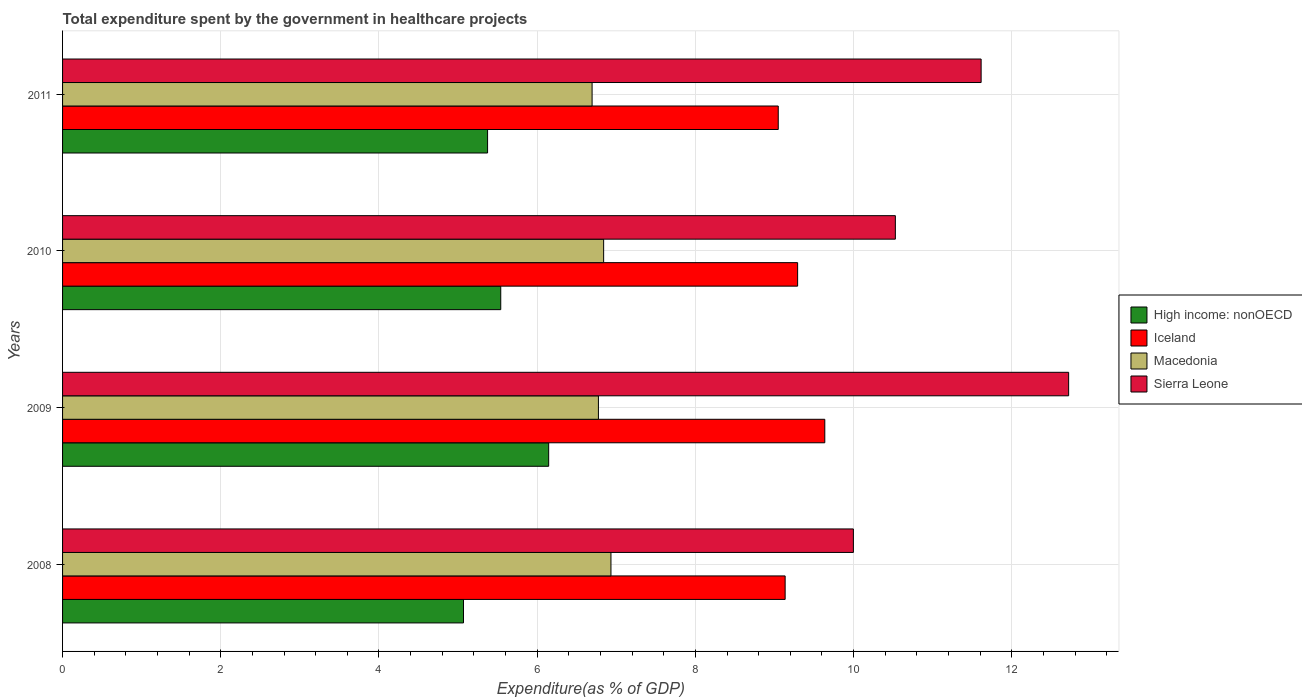How many different coloured bars are there?
Provide a succinct answer. 4. How many groups of bars are there?
Make the answer very short. 4. Are the number of bars per tick equal to the number of legend labels?
Keep it short and to the point. Yes. Are the number of bars on each tick of the Y-axis equal?
Offer a terse response. Yes. How many bars are there on the 1st tick from the bottom?
Ensure brevity in your answer.  4. What is the total expenditure spent by the government in healthcare projects in Macedonia in 2011?
Your answer should be compact. 6.69. Across all years, what is the maximum total expenditure spent by the government in healthcare projects in Iceland?
Make the answer very short. 9.64. Across all years, what is the minimum total expenditure spent by the government in healthcare projects in Macedonia?
Keep it short and to the point. 6.69. In which year was the total expenditure spent by the government in healthcare projects in High income: nonOECD maximum?
Your answer should be very brief. 2009. What is the total total expenditure spent by the government in healthcare projects in Iceland in the graph?
Your response must be concise. 37.11. What is the difference between the total expenditure spent by the government in healthcare projects in Sierra Leone in 2008 and that in 2009?
Make the answer very short. -2.72. What is the difference between the total expenditure spent by the government in healthcare projects in Macedonia in 2011 and the total expenditure spent by the government in healthcare projects in Sierra Leone in 2008?
Provide a short and direct response. -3.3. What is the average total expenditure spent by the government in healthcare projects in High income: nonOECD per year?
Keep it short and to the point. 5.53. In the year 2011, what is the difference between the total expenditure spent by the government in healthcare projects in Iceland and total expenditure spent by the government in healthcare projects in High income: nonOECD?
Give a very brief answer. 3.67. What is the ratio of the total expenditure spent by the government in healthcare projects in Sierra Leone in 2009 to that in 2010?
Make the answer very short. 1.21. Is the total expenditure spent by the government in healthcare projects in High income: nonOECD in 2008 less than that in 2009?
Make the answer very short. Yes. Is the difference between the total expenditure spent by the government in healthcare projects in Iceland in 2008 and 2011 greater than the difference between the total expenditure spent by the government in healthcare projects in High income: nonOECD in 2008 and 2011?
Keep it short and to the point. Yes. What is the difference between the highest and the second highest total expenditure spent by the government in healthcare projects in Macedonia?
Your answer should be very brief. 0.09. What is the difference between the highest and the lowest total expenditure spent by the government in healthcare projects in Iceland?
Give a very brief answer. 0.59. Is it the case that in every year, the sum of the total expenditure spent by the government in healthcare projects in High income: nonOECD and total expenditure spent by the government in healthcare projects in Iceland is greater than the sum of total expenditure spent by the government in healthcare projects in Macedonia and total expenditure spent by the government in healthcare projects in Sierra Leone?
Provide a succinct answer. Yes. What does the 4th bar from the top in 2011 represents?
Provide a succinct answer. High income: nonOECD. What does the 4th bar from the bottom in 2011 represents?
Keep it short and to the point. Sierra Leone. How many bars are there?
Your answer should be compact. 16. How many years are there in the graph?
Your answer should be very brief. 4. What is the difference between two consecutive major ticks on the X-axis?
Give a very brief answer. 2. Are the values on the major ticks of X-axis written in scientific E-notation?
Ensure brevity in your answer.  No. Does the graph contain grids?
Provide a succinct answer. Yes. What is the title of the graph?
Ensure brevity in your answer.  Total expenditure spent by the government in healthcare projects. What is the label or title of the X-axis?
Provide a succinct answer. Expenditure(as % of GDP). What is the label or title of the Y-axis?
Your answer should be very brief. Years. What is the Expenditure(as % of GDP) in High income: nonOECD in 2008?
Ensure brevity in your answer.  5.07. What is the Expenditure(as % of GDP) in Iceland in 2008?
Keep it short and to the point. 9.13. What is the Expenditure(as % of GDP) in Macedonia in 2008?
Offer a terse response. 6.93. What is the Expenditure(as % of GDP) in Sierra Leone in 2008?
Ensure brevity in your answer.  10. What is the Expenditure(as % of GDP) of High income: nonOECD in 2009?
Your answer should be compact. 6.15. What is the Expenditure(as % of GDP) in Iceland in 2009?
Ensure brevity in your answer.  9.64. What is the Expenditure(as % of GDP) of Macedonia in 2009?
Make the answer very short. 6.77. What is the Expenditure(as % of GDP) in Sierra Leone in 2009?
Keep it short and to the point. 12.72. What is the Expenditure(as % of GDP) of High income: nonOECD in 2010?
Give a very brief answer. 5.54. What is the Expenditure(as % of GDP) in Iceland in 2010?
Give a very brief answer. 9.29. What is the Expenditure(as % of GDP) of Macedonia in 2010?
Your answer should be very brief. 6.84. What is the Expenditure(as % of GDP) in Sierra Leone in 2010?
Offer a very short reply. 10.53. What is the Expenditure(as % of GDP) of High income: nonOECD in 2011?
Offer a terse response. 5.37. What is the Expenditure(as % of GDP) of Iceland in 2011?
Provide a succinct answer. 9.05. What is the Expenditure(as % of GDP) in Macedonia in 2011?
Offer a very short reply. 6.69. What is the Expenditure(as % of GDP) of Sierra Leone in 2011?
Provide a succinct answer. 11.61. Across all years, what is the maximum Expenditure(as % of GDP) in High income: nonOECD?
Your answer should be compact. 6.15. Across all years, what is the maximum Expenditure(as % of GDP) of Iceland?
Give a very brief answer. 9.64. Across all years, what is the maximum Expenditure(as % of GDP) in Macedonia?
Make the answer very short. 6.93. Across all years, what is the maximum Expenditure(as % of GDP) in Sierra Leone?
Provide a short and direct response. 12.72. Across all years, what is the minimum Expenditure(as % of GDP) in High income: nonOECD?
Your answer should be compact. 5.07. Across all years, what is the minimum Expenditure(as % of GDP) in Iceland?
Your answer should be very brief. 9.05. Across all years, what is the minimum Expenditure(as % of GDP) of Macedonia?
Keep it short and to the point. 6.69. Across all years, what is the minimum Expenditure(as % of GDP) of Sierra Leone?
Your answer should be compact. 10. What is the total Expenditure(as % of GDP) of High income: nonOECD in the graph?
Ensure brevity in your answer.  22.13. What is the total Expenditure(as % of GDP) of Iceland in the graph?
Your answer should be compact. 37.11. What is the total Expenditure(as % of GDP) of Macedonia in the graph?
Provide a short and direct response. 27.24. What is the total Expenditure(as % of GDP) in Sierra Leone in the graph?
Provide a short and direct response. 44.85. What is the difference between the Expenditure(as % of GDP) in High income: nonOECD in 2008 and that in 2009?
Provide a short and direct response. -1.08. What is the difference between the Expenditure(as % of GDP) of Iceland in 2008 and that in 2009?
Keep it short and to the point. -0.5. What is the difference between the Expenditure(as % of GDP) of Macedonia in 2008 and that in 2009?
Offer a terse response. 0.16. What is the difference between the Expenditure(as % of GDP) of Sierra Leone in 2008 and that in 2009?
Provide a short and direct response. -2.72. What is the difference between the Expenditure(as % of GDP) of High income: nonOECD in 2008 and that in 2010?
Your response must be concise. -0.47. What is the difference between the Expenditure(as % of GDP) of Iceland in 2008 and that in 2010?
Your answer should be compact. -0.16. What is the difference between the Expenditure(as % of GDP) in Macedonia in 2008 and that in 2010?
Offer a terse response. 0.09. What is the difference between the Expenditure(as % of GDP) in Sierra Leone in 2008 and that in 2010?
Offer a terse response. -0.53. What is the difference between the Expenditure(as % of GDP) of High income: nonOECD in 2008 and that in 2011?
Offer a terse response. -0.3. What is the difference between the Expenditure(as % of GDP) in Iceland in 2008 and that in 2011?
Provide a succinct answer. 0.09. What is the difference between the Expenditure(as % of GDP) of Macedonia in 2008 and that in 2011?
Your answer should be compact. 0.24. What is the difference between the Expenditure(as % of GDP) in Sierra Leone in 2008 and that in 2011?
Keep it short and to the point. -1.61. What is the difference between the Expenditure(as % of GDP) of High income: nonOECD in 2009 and that in 2010?
Make the answer very short. 0.61. What is the difference between the Expenditure(as % of GDP) in Iceland in 2009 and that in 2010?
Offer a terse response. 0.34. What is the difference between the Expenditure(as % of GDP) of Macedonia in 2009 and that in 2010?
Give a very brief answer. -0.07. What is the difference between the Expenditure(as % of GDP) in Sierra Leone in 2009 and that in 2010?
Ensure brevity in your answer.  2.19. What is the difference between the Expenditure(as % of GDP) of High income: nonOECD in 2009 and that in 2011?
Make the answer very short. 0.77. What is the difference between the Expenditure(as % of GDP) in Iceland in 2009 and that in 2011?
Your response must be concise. 0.59. What is the difference between the Expenditure(as % of GDP) of Sierra Leone in 2009 and that in 2011?
Provide a short and direct response. 1.11. What is the difference between the Expenditure(as % of GDP) of High income: nonOECD in 2010 and that in 2011?
Make the answer very short. 0.17. What is the difference between the Expenditure(as % of GDP) of Iceland in 2010 and that in 2011?
Ensure brevity in your answer.  0.24. What is the difference between the Expenditure(as % of GDP) of Macedonia in 2010 and that in 2011?
Your response must be concise. 0.15. What is the difference between the Expenditure(as % of GDP) in Sierra Leone in 2010 and that in 2011?
Offer a terse response. -1.08. What is the difference between the Expenditure(as % of GDP) of High income: nonOECD in 2008 and the Expenditure(as % of GDP) of Iceland in 2009?
Your answer should be compact. -4.57. What is the difference between the Expenditure(as % of GDP) of High income: nonOECD in 2008 and the Expenditure(as % of GDP) of Macedonia in 2009?
Ensure brevity in your answer.  -1.71. What is the difference between the Expenditure(as % of GDP) in High income: nonOECD in 2008 and the Expenditure(as % of GDP) in Sierra Leone in 2009?
Offer a very short reply. -7.65. What is the difference between the Expenditure(as % of GDP) of Iceland in 2008 and the Expenditure(as % of GDP) of Macedonia in 2009?
Your answer should be compact. 2.36. What is the difference between the Expenditure(as % of GDP) of Iceland in 2008 and the Expenditure(as % of GDP) of Sierra Leone in 2009?
Offer a terse response. -3.58. What is the difference between the Expenditure(as % of GDP) in Macedonia in 2008 and the Expenditure(as % of GDP) in Sierra Leone in 2009?
Ensure brevity in your answer.  -5.79. What is the difference between the Expenditure(as % of GDP) of High income: nonOECD in 2008 and the Expenditure(as % of GDP) of Iceland in 2010?
Keep it short and to the point. -4.22. What is the difference between the Expenditure(as % of GDP) of High income: nonOECD in 2008 and the Expenditure(as % of GDP) of Macedonia in 2010?
Provide a short and direct response. -1.77. What is the difference between the Expenditure(as % of GDP) in High income: nonOECD in 2008 and the Expenditure(as % of GDP) in Sierra Leone in 2010?
Offer a very short reply. -5.46. What is the difference between the Expenditure(as % of GDP) of Iceland in 2008 and the Expenditure(as % of GDP) of Macedonia in 2010?
Provide a succinct answer. 2.29. What is the difference between the Expenditure(as % of GDP) of Iceland in 2008 and the Expenditure(as % of GDP) of Sierra Leone in 2010?
Provide a short and direct response. -1.39. What is the difference between the Expenditure(as % of GDP) in Macedonia in 2008 and the Expenditure(as % of GDP) in Sierra Leone in 2010?
Your answer should be compact. -3.6. What is the difference between the Expenditure(as % of GDP) of High income: nonOECD in 2008 and the Expenditure(as % of GDP) of Iceland in 2011?
Provide a short and direct response. -3.98. What is the difference between the Expenditure(as % of GDP) in High income: nonOECD in 2008 and the Expenditure(as % of GDP) in Macedonia in 2011?
Make the answer very short. -1.63. What is the difference between the Expenditure(as % of GDP) of High income: nonOECD in 2008 and the Expenditure(as % of GDP) of Sierra Leone in 2011?
Give a very brief answer. -6.54. What is the difference between the Expenditure(as % of GDP) of Iceland in 2008 and the Expenditure(as % of GDP) of Macedonia in 2011?
Your response must be concise. 2.44. What is the difference between the Expenditure(as % of GDP) in Iceland in 2008 and the Expenditure(as % of GDP) in Sierra Leone in 2011?
Keep it short and to the point. -2.48. What is the difference between the Expenditure(as % of GDP) in Macedonia in 2008 and the Expenditure(as % of GDP) in Sierra Leone in 2011?
Give a very brief answer. -4.68. What is the difference between the Expenditure(as % of GDP) in High income: nonOECD in 2009 and the Expenditure(as % of GDP) in Iceland in 2010?
Make the answer very short. -3.15. What is the difference between the Expenditure(as % of GDP) of High income: nonOECD in 2009 and the Expenditure(as % of GDP) of Macedonia in 2010?
Offer a very short reply. -0.69. What is the difference between the Expenditure(as % of GDP) of High income: nonOECD in 2009 and the Expenditure(as % of GDP) of Sierra Leone in 2010?
Provide a succinct answer. -4.38. What is the difference between the Expenditure(as % of GDP) of Iceland in 2009 and the Expenditure(as % of GDP) of Macedonia in 2010?
Make the answer very short. 2.8. What is the difference between the Expenditure(as % of GDP) in Iceland in 2009 and the Expenditure(as % of GDP) in Sierra Leone in 2010?
Keep it short and to the point. -0.89. What is the difference between the Expenditure(as % of GDP) in Macedonia in 2009 and the Expenditure(as % of GDP) in Sierra Leone in 2010?
Your response must be concise. -3.75. What is the difference between the Expenditure(as % of GDP) of High income: nonOECD in 2009 and the Expenditure(as % of GDP) of Iceland in 2011?
Keep it short and to the point. -2.9. What is the difference between the Expenditure(as % of GDP) in High income: nonOECD in 2009 and the Expenditure(as % of GDP) in Macedonia in 2011?
Provide a succinct answer. -0.55. What is the difference between the Expenditure(as % of GDP) in High income: nonOECD in 2009 and the Expenditure(as % of GDP) in Sierra Leone in 2011?
Ensure brevity in your answer.  -5.47. What is the difference between the Expenditure(as % of GDP) of Iceland in 2009 and the Expenditure(as % of GDP) of Macedonia in 2011?
Provide a short and direct response. 2.94. What is the difference between the Expenditure(as % of GDP) in Iceland in 2009 and the Expenditure(as % of GDP) in Sierra Leone in 2011?
Your response must be concise. -1.98. What is the difference between the Expenditure(as % of GDP) of Macedonia in 2009 and the Expenditure(as % of GDP) of Sierra Leone in 2011?
Offer a terse response. -4.84. What is the difference between the Expenditure(as % of GDP) of High income: nonOECD in 2010 and the Expenditure(as % of GDP) of Iceland in 2011?
Keep it short and to the point. -3.51. What is the difference between the Expenditure(as % of GDP) in High income: nonOECD in 2010 and the Expenditure(as % of GDP) in Macedonia in 2011?
Your answer should be very brief. -1.15. What is the difference between the Expenditure(as % of GDP) of High income: nonOECD in 2010 and the Expenditure(as % of GDP) of Sierra Leone in 2011?
Offer a very short reply. -6.07. What is the difference between the Expenditure(as % of GDP) in Iceland in 2010 and the Expenditure(as % of GDP) in Macedonia in 2011?
Offer a terse response. 2.6. What is the difference between the Expenditure(as % of GDP) of Iceland in 2010 and the Expenditure(as % of GDP) of Sierra Leone in 2011?
Ensure brevity in your answer.  -2.32. What is the difference between the Expenditure(as % of GDP) in Macedonia in 2010 and the Expenditure(as % of GDP) in Sierra Leone in 2011?
Make the answer very short. -4.77. What is the average Expenditure(as % of GDP) of High income: nonOECD per year?
Offer a terse response. 5.53. What is the average Expenditure(as % of GDP) of Iceland per year?
Your answer should be very brief. 9.28. What is the average Expenditure(as % of GDP) of Macedonia per year?
Offer a very short reply. 6.81. What is the average Expenditure(as % of GDP) in Sierra Leone per year?
Your answer should be very brief. 11.21. In the year 2008, what is the difference between the Expenditure(as % of GDP) of High income: nonOECD and Expenditure(as % of GDP) of Iceland?
Offer a terse response. -4.07. In the year 2008, what is the difference between the Expenditure(as % of GDP) of High income: nonOECD and Expenditure(as % of GDP) of Macedonia?
Offer a terse response. -1.86. In the year 2008, what is the difference between the Expenditure(as % of GDP) in High income: nonOECD and Expenditure(as % of GDP) in Sierra Leone?
Keep it short and to the point. -4.93. In the year 2008, what is the difference between the Expenditure(as % of GDP) in Iceland and Expenditure(as % of GDP) in Macedonia?
Provide a succinct answer. 2.2. In the year 2008, what is the difference between the Expenditure(as % of GDP) of Iceland and Expenditure(as % of GDP) of Sierra Leone?
Give a very brief answer. -0.86. In the year 2008, what is the difference between the Expenditure(as % of GDP) of Macedonia and Expenditure(as % of GDP) of Sierra Leone?
Offer a terse response. -3.06. In the year 2009, what is the difference between the Expenditure(as % of GDP) of High income: nonOECD and Expenditure(as % of GDP) of Iceland?
Provide a short and direct response. -3.49. In the year 2009, what is the difference between the Expenditure(as % of GDP) in High income: nonOECD and Expenditure(as % of GDP) in Macedonia?
Make the answer very short. -0.63. In the year 2009, what is the difference between the Expenditure(as % of GDP) of High income: nonOECD and Expenditure(as % of GDP) of Sierra Leone?
Offer a very short reply. -6.57. In the year 2009, what is the difference between the Expenditure(as % of GDP) in Iceland and Expenditure(as % of GDP) in Macedonia?
Offer a very short reply. 2.86. In the year 2009, what is the difference between the Expenditure(as % of GDP) in Iceland and Expenditure(as % of GDP) in Sierra Leone?
Offer a terse response. -3.08. In the year 2009, what is the difference between the Expenditure(as % of GDP) in Macedonia and Expenditure(as % of GDP) in Sierra Leone?
Your response must be concise. -5.94. In the year 2010, what is the difference between the Expenditure(as % of GDP) in High income: nonOECD and Expenditure(as % of GDP) in Iceland?
Make the answer very short. -3.75. In the year 2010, what is the difference between the Expenditure(as % of GDP) of High income: nonOECD and Expenditure(as % of GDP) of Macedonia?
Your answer should be compact. -1.3. In the year 2010, what is the difference between the Expenditure(as % of GDP) of High income: nonOECD and Expenditure(as % of GDP) of Sierra Leone?
Your response must be concise. -4.99. In the year 2010, what is the difference between the Expenditure(as % of GDP) of Iceland and Expenditure(as % of GDP) of Macedonia?
Provide a succinct answer. 2.45. In the year 2010, what is the difference between the Expenditure(as % of GDP) in Iceland and Expenditure(as % of GDP) in Sierra Leone?
Give a very brief answer. -1.24. In the year 2010, what is the difference between the Expenditure(as % of GDP) of Macedonia and Expenditure(as % of GDP) of Sierra Leone?
Keep it short and to the point. -3.69. In the year 2011, what is the difference between the Expenditure(as % of GDP) of High income: nonOECD and Expenditure(as % of GDP) of Iceland?
Your response must be concise. -3.67. In the year 2011, what is the difference between the Expenditure(as % of GDP) in High income: nonOECD and Expenditure(as % of GDP) in Macedonia?
Keep it short and to the point. -1.32. In the year 2011, what is the difference between the Expenditure(as % of GDP) of High income: nonOECD and Expenditure(as % of GDP) of Sierra Leone?
Offer a very short reply. -6.24. In the year 2011, what is the difference between the Expenditure(as % of GDP) of Iceland and Expenditure(as % of GDP) of Macedonia?
Give a very brief answer. 2.35. In the year 2011, what is the difference between the Expenditure(as % of GDP) of Iceland and Expenditure(as % of GDP) of Sierra Leone?
Make the answer very short. -2.56. In the year 2011, what is the difference between the Expenditure(as % of GDP) in Macedonia and Expenditure(as % of GDP) in Sierra Leone?
Your answer should be very brief. -4.92. What is the ratio of the Expenditure(as % of GDP) of High income: nonOECD in 2008 to that in 2009?
Ensure brevity in your answer.  0.82. What is the ratio of the Expenditure(as % of GDP) in Iceland in 2008 to that in 2009?
Provide a short and direct response. 0.95. What is the ratio of the Expenditure(as % of GDP) in Macedonia in 2008 to that in 2009?
Your answer should be compact. 1.02. What is the ratio of the Expenditure(as % of GDP) in Sierra Leone in 2008 to that in 2009?
Provide a succinct answer. 0.79. What is the ratio of the Expenditure(as % of GDP) in High income: nonOECD in 2008 to that in 2010?
Your response must be concise. 0.92. What is the ratio of the Expenditure(as % of GDP) in Macedonia in 2008 to that in 2010?
Your answer should be compact. 1.01. What is the ratio of the Expenditure(as % of GDP) of Sierra Leone in 2008 to that in 2010?
Your answer should be compact. 0.95. What is the ratio of the Expenditure(as % of GDP) in High income: nonOECD in 2008 to that in 2011?
Your response must be concise. 0.94. What is the ratio of the Expenditure(as % of GDP) of Iceland in 2008 to that in 2011?
Provide a short and direct response. 1.01. What is the ratio of the Expenditure(as % of GDP) in Macedonia in 2008 to that in 2011?
Make the answer very short. 1.04. What is the ratio of the Expenditure(as % of GDP) in Sierra Leone in 2008 to that in 2011?
Offer a terse response. 0.86. What is the ratio of the Expenditure(as % of GDP) of High income: nonOECD in 2009 to that in 2010?
Keep it short and to the point. 1.11. What is the ratio of the Expenditure(as % of GDP) in Iceland in 2009 to that in 2010?
Provide a short and direct response. 1.04. What is the ratio of the Expenditure(as % of GDP) in Sierra Leone in 2009 to that in 2010?
Offer a terse response. 1.21. What is the ratio of the Expenditure(as % of GDP) of High income: nonOECD in 2009 to that in 2011?
Keep it short and to the point. 1.14. What is the ratio of the Expenditure(as % of GDP) in Iceland in 2009 to that in 2011?
Ensure brevity in your answer.  1.06. What is the ratio of the Expenditure(as % of GDP) in Macedonia in 2009 to that in 2011?
Your answer should be very brief. 1.01. What is the ratio of the Expenditure(as % of GDP) in Sierra Leone in 2009 to that in 2011?
Your answer should be compact. 1.1. What is the ratio of the Expenditure(as % of GDP) of High income: nonOECD in 2010 to that in 2011?
Give a very brief answer. 1.03. What is the ratio of the Expenditure(as % of GDP) in Iceland in 2010 to that in 2011?
Your answer should be compact. 1.03. What is the ratio of the Expenditure(as % of GDP) of Macedonia in 2010 to that in 2011?
Provide a short and direct response. 1.02. What is the ratio of the Expenditure(as % of GDP) in Sierra Leone in 2010 to that in 2011?
Your answer should be very brief. 0.91. What is the difference between the highest and the second highest Expenditure(as % of GDP) of High income: nonOECD?
Your answer should be compact. 0.61. What is the difference between the highest and the second highest Expenditure(as % of GDP) of Iceland?
Offer a terse response. 0.34. What is the difference between the highest and the second highest Expenditure(as % of GDP) of Macedonia?
Offer a very short reply. 0.09. What is the difference between the highest and the second highest Expenditure(as % of GDP) of Sierra Leone?
Your answer should be compact. 1.11. What is the difference between the highest and the lowest Expenditure(as % of GDP) of High income: nonOECD?
Provide a short and direct response. 1.08. What is the difference between the highest and the lowest Expenditure(as % of GDP) in Iceland?
Provide a short and direct response. 0.59. What is the difference between the highest and the lowest Expenditure(as % of GDP) of Macedonia?
Provide a short and direct response. 0.24. What is the difference between the highest and the lowest Expenditure(as % of GDP) in Sierra Leone?
Your answer should be compact. 2.72. 